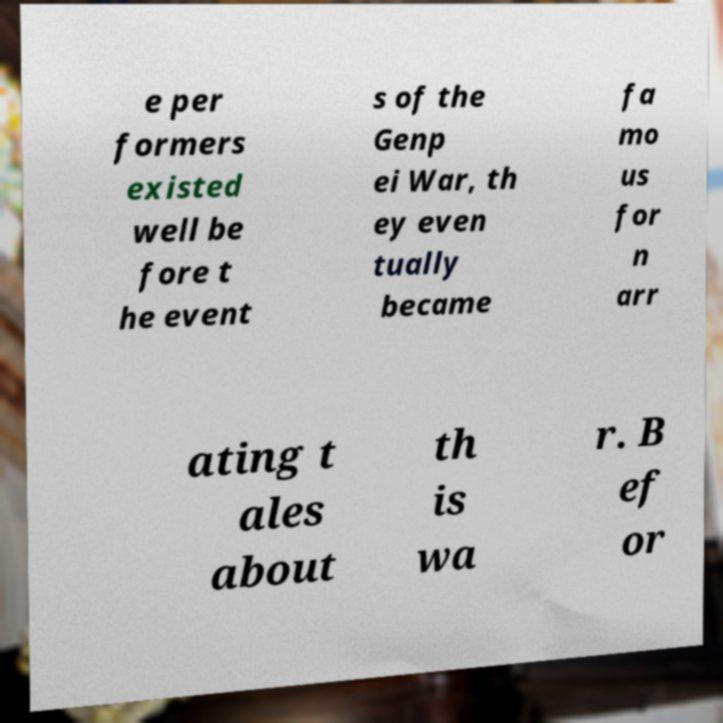What messages or text are displayed in this image? I need them in a readable, typed format. e per formers existed well be fore t he event s of the Genp ei War, th ey even tually became fa mo us for n arr ating t ales about th is wa r. B ef or 